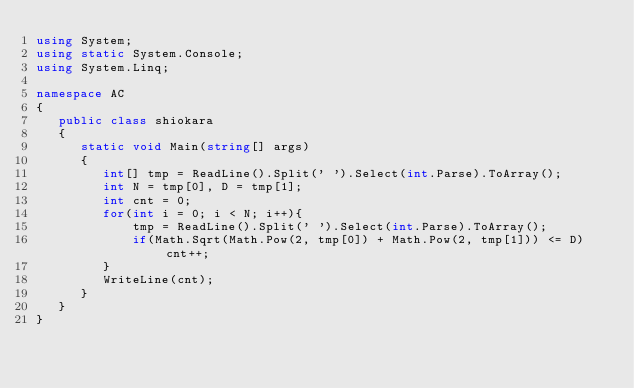<code> <loc_0><loc_0><loc_500><loc_500><_C#_>using System;
using static System.Console;
using System.Linq;

namespace AC
{
   public class shiokara
   {
      static void Main(string[] args)
      {
         int[] tmp = ReadLine().Split(' ').Select(int.Parse).ToArray();
         int N = tmp[0], D = tmp[1];
         int cnt = 0;
         for(int i = 0; i < N; i++){
             tmp = ReadLine().Split(' ').Select(int.Parse).ToArray();
             if(Math.Sqrt(Math.Pow(2, tmp[0]) + Math.Pow(2, tmp[1])) <= D) cnt++;
         }
         WriteLine(cnt);
      }
   }
}</code> 